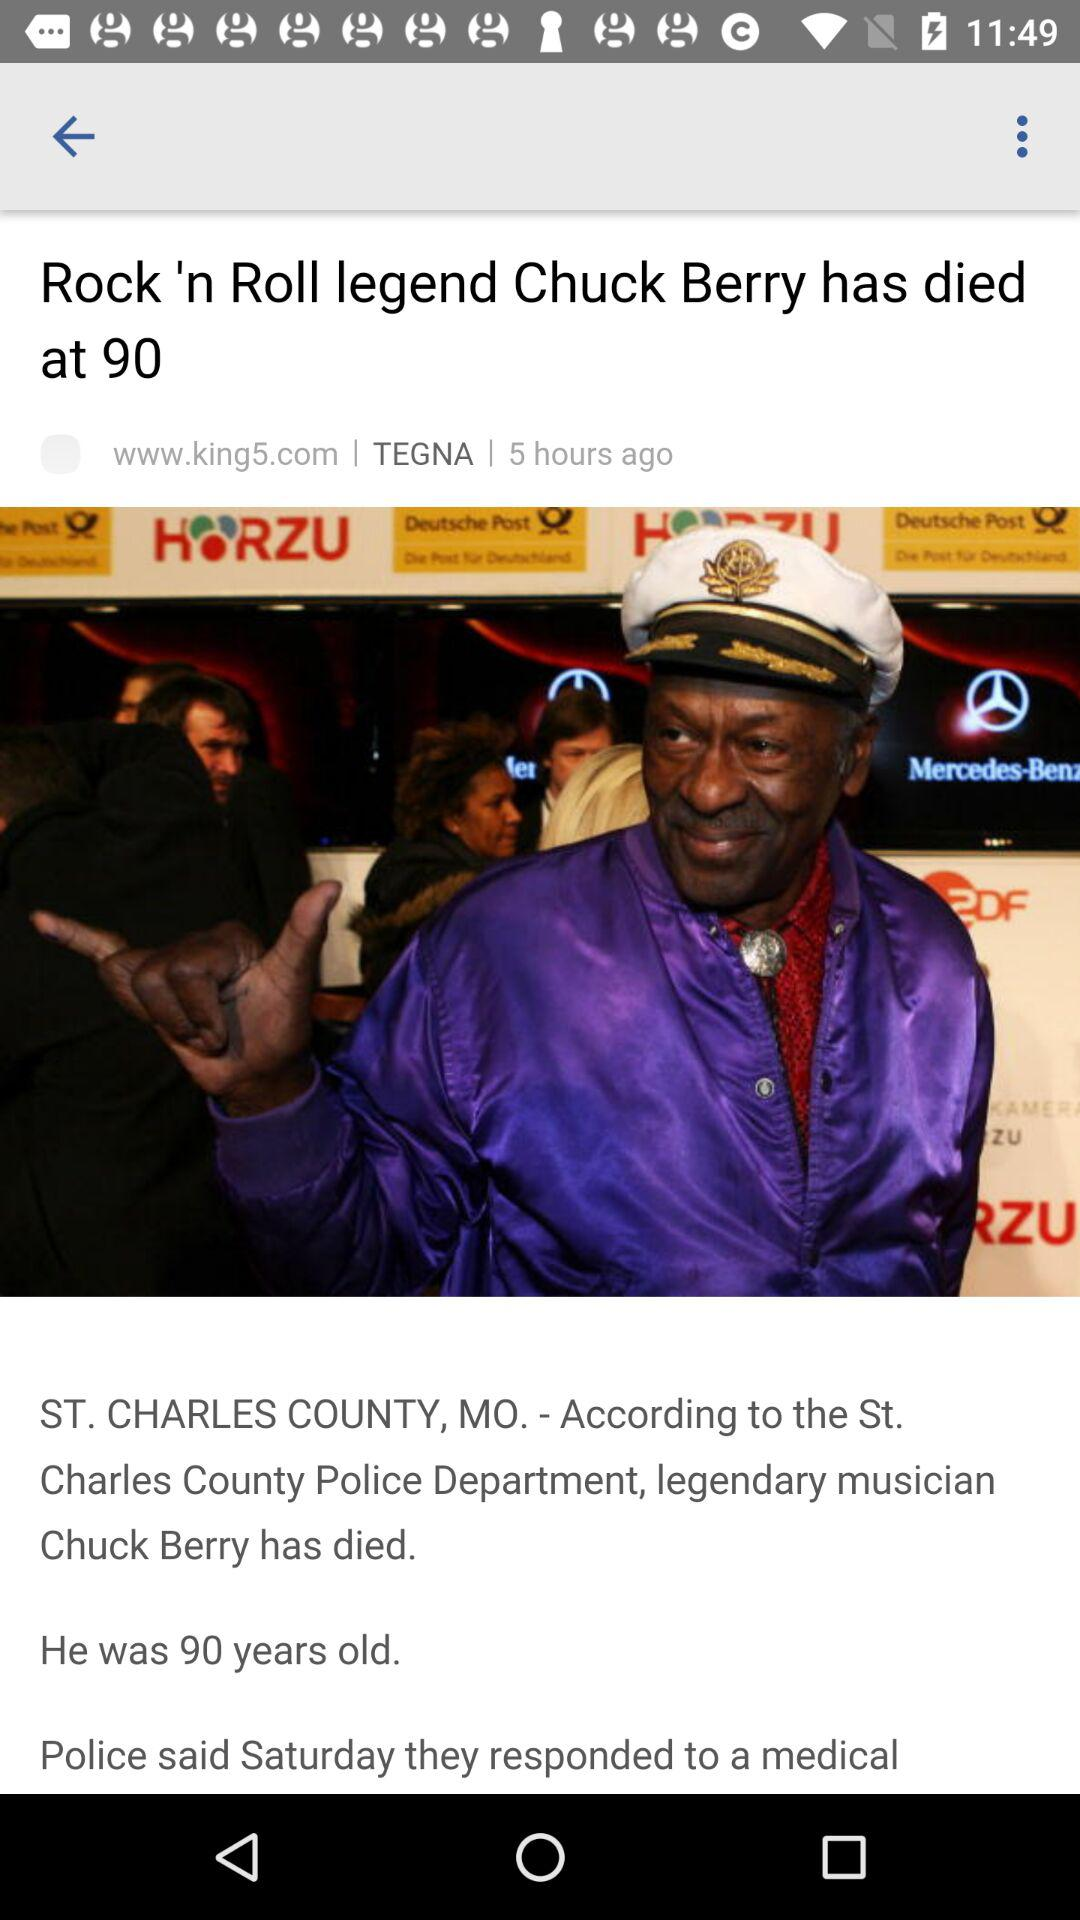What is the given website? The given website is www.king5.com. 